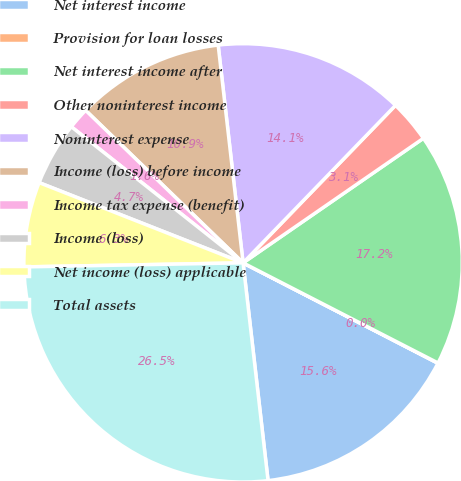Convert chart. <chart><loc_0><loc_0><loc_500><loc_500><pie_chart><fcel>Net interest income<fcel>Provision for loan losses<fcel>Net interest income after<fcel>Other noninterest income<fcel>Noninterest expense<fcel>Income (loss) before income<fcel>Income tax expense (benefit)<fcel>Income (loss)<fcel>Net income (loss) applicable<fcel>Total assets<nl><fcel>15.61%<fcel>0.02%<fcel>17.17%<fcel>3.14%<fcel>14.05%<fcel>10.94%<fcel>1.58%<fcel>4.7%<fcel>6.26%<fcel>26.52%<nl></chart> 